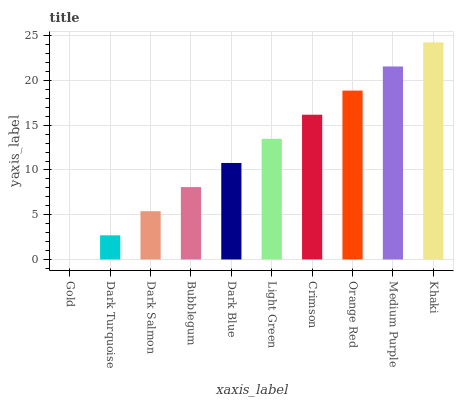Is Dark Turquoise the minimum?
Answer yes or no. No. Is Dark Turquoise the maximum?
Answer yes or no. No. Is Dark Turquoise greater than Gold?
Answer yes or no. Yes. Is Gold less than Dark Turquoise?
Answer yes or no. Yes. Is Gold greater than Dark Turquoise?
Answer yes or no. No. Is Dark Turquoise less than Gold?
Answer yes or no. No. Is Light Green the high median?
Answer yes or no. Yes. Is Dark Blue the low median?
Answer yes or no. Yes. Is Crimson the high median?
Answer yes or no. No. Is Dark Turquoise the low median?
Answer yes or no. No. 